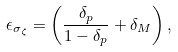Convert formula to latex. <formula><loc_0><loc_0><loc_500><loc_500>\epsilon _ { \sigma _ { \zeta } } = \left ( \frac { \delta _ { p } } { 1 - \delta _ { p } } + \delta _ { M } \right ) ,</formula> 